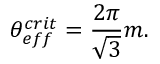<formula> <loc_0><loc_0><loc_500><loc_500>\theta _ { e f f } ^ { c r i t } = \frac { 2 \pi } { \sqrt { 3 } } m .</formula> 